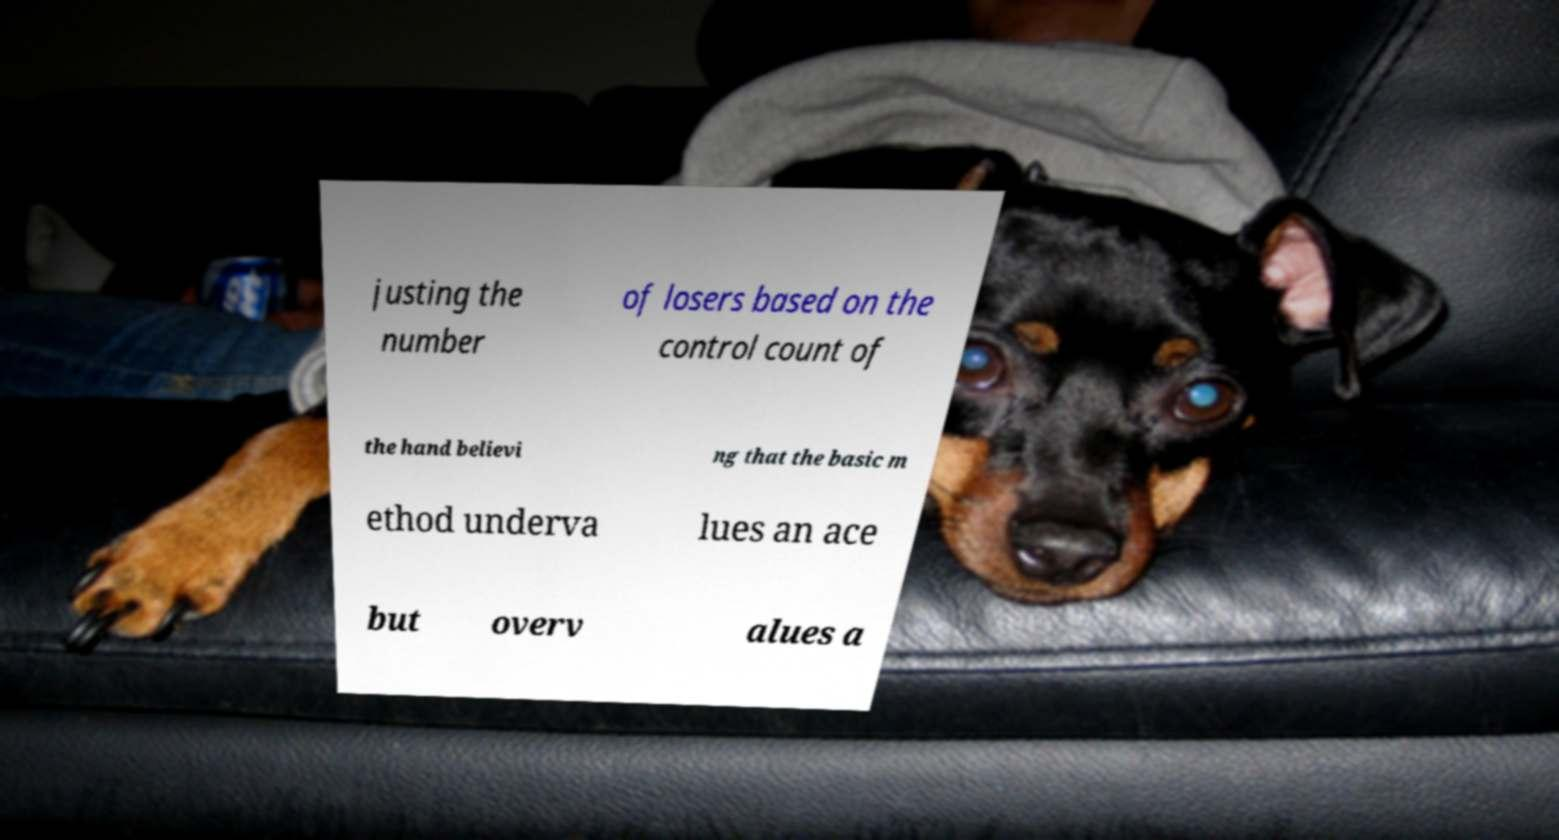For documentation purposes, I need the text within this image transcribed. Could you provide that? justing the number of losers based on the control count of the hand believi ng that the basic m ethod underva lues an ace but overv alues a 